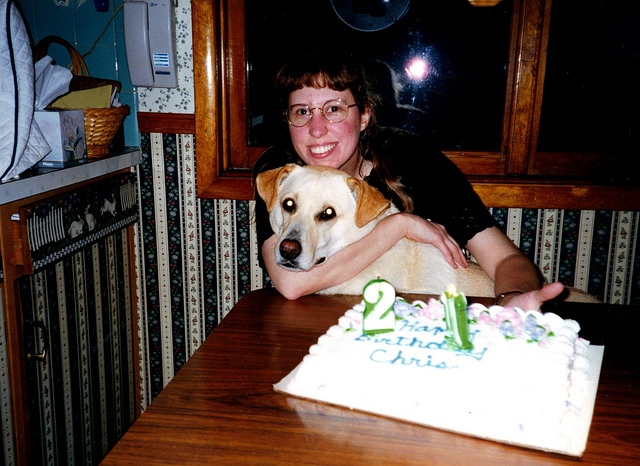Extract all visible text content from this image. 2 HaM birthday Chris 